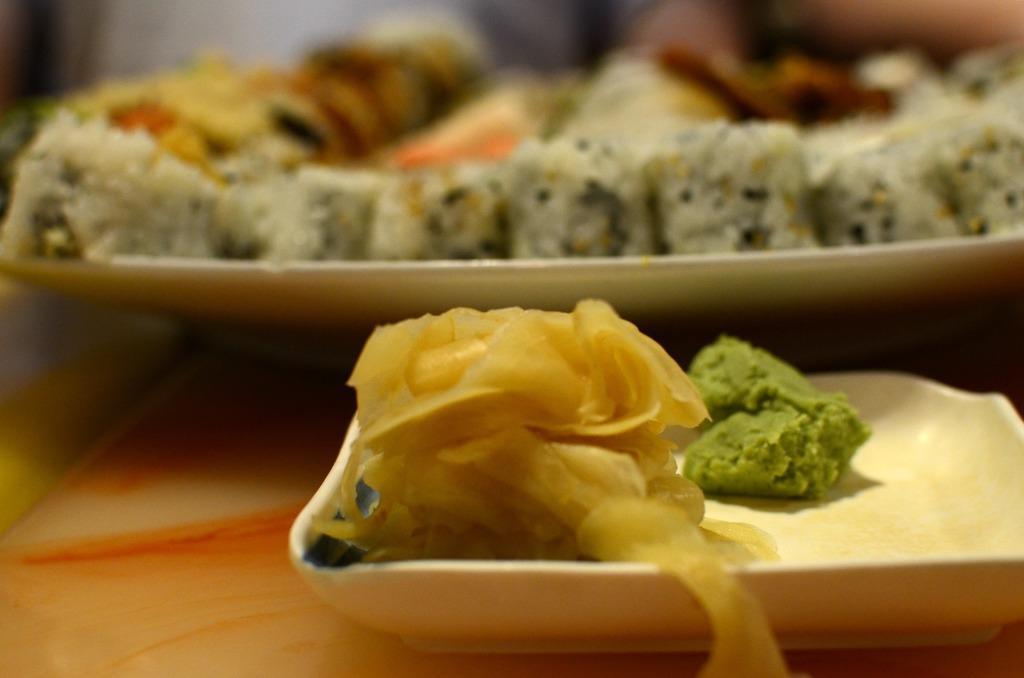In one or two sentences, can you explain what this image depicts? In the image there are some food items served on the plates. 